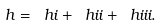Convert formula to latex. <formula><loc_0><loc_0><loc_500><loc_500>h = \ h i + \ h i i + \ h i i i .</formula> 